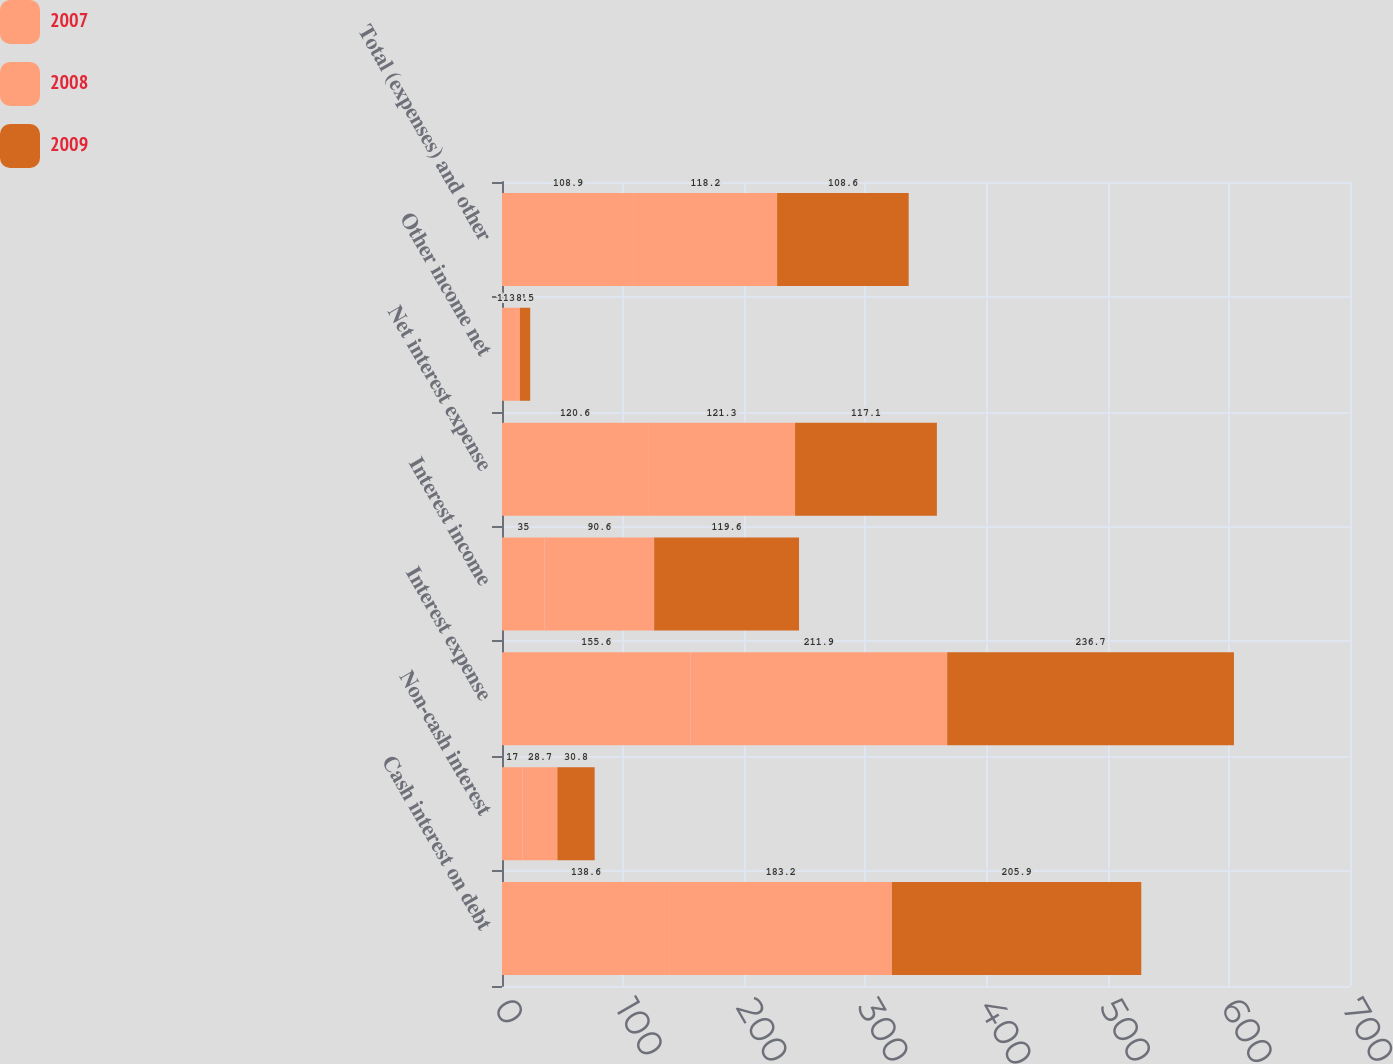<chart> <loc_0><loc_0><loc_500><loc_500><stacked_bar_chart><ecel><fcel>Cash interest on debt<fcel>Non-cash interest<fcel>Interest expense<fcel>Interest income<fcel>Net interest expense<fcel>Other income net<fcel>Total (expenses) and other<nl><fcel>2007<fcel>138.6<fcel>17<fcel>155.6<fcel>35<fcel>120.6<fcel>11.7<fcel>108.9<nl><fcel>2008<fcel>183.2<fcel>28.7<fcel>211.9<fcel>90.6<fcel>121.3<fcel>3.1<fcel>118.2<nl><fcel>2009<fcel>205.9<fcel>30.8<fcel>236.7<fcel>119.6<fcel>117.1<fcel>8.5<fcel>108.6<nl></chart> 